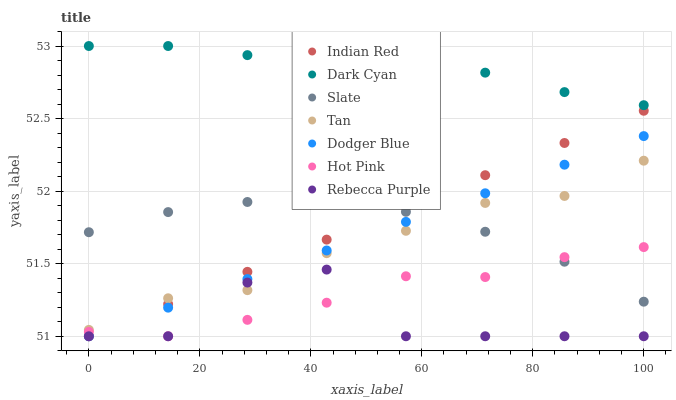Does Rebecca Purple have the minimum area under the curve?
Answer yes or no. Yes. Does Dark Cyan have the maximum area under the curve?
Answer yes or no. Yes. Does Hot Pink have the minimum area under the curve?
Answer yes or no. No. Does Hot Pink have the maximum area under the curve?
Answer yes or no. No. Is Indian Red the smoothest?
Answer yes or no. Yes. Is Rebecca Purple the roughest?
Answer yes or no. Yes. Is Hot Pink the smoothest?
Answer yes or no. No. Is Hot Pink the roughest?
Answer yes or no. No. Does Hot Pink have the lowest value?
Answer yes or no. Yes. Does Dark Cyan have the lowest value?
Answer yes or no. No. Does Dark Cyan have the highest value?
Answer yes or no. Yes. Does Hot Pink have the highest value?
Answer yes or no. No. Is Hot Pink less than Tan?
Answer yes or no. Yes. Is Tan greater than Hot Pink?
Answer yes or no. Yes. Does Slate intersect Indian Red?
Answer yes or no. Yes. Is Slate less than Indian Red?
Answer yes or no. No. Is Slate greater than Indian Red?
Answer yes or no. No. Does Hot Pink intersect Tan?
Answer yes or no. No. 